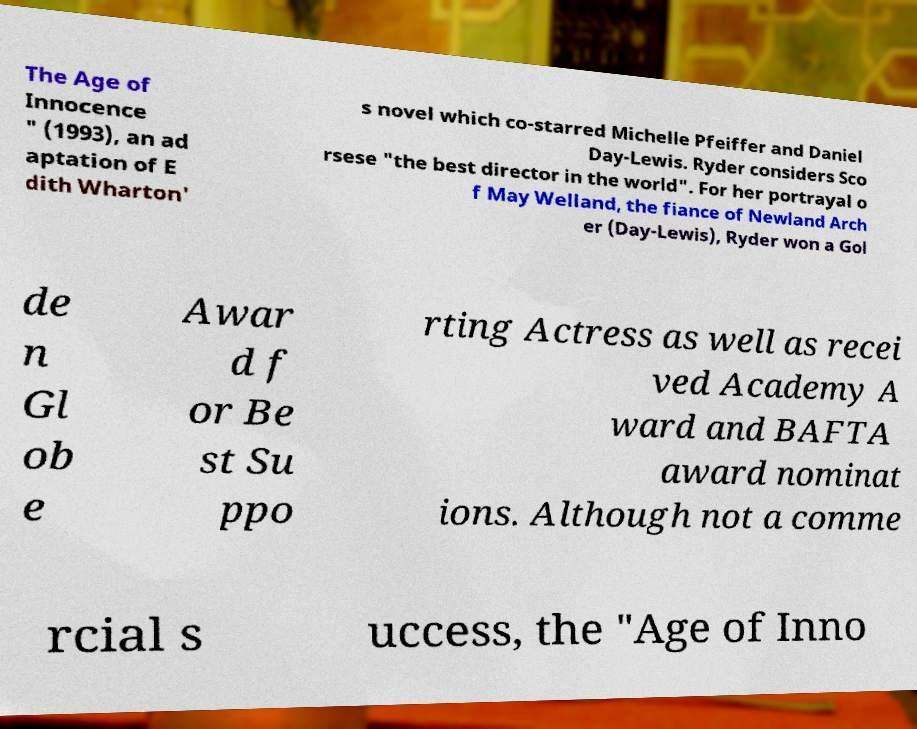For documentation purposes, I need the text within this image transcribed. Could you provide that? The Age of Innocence " (1993), an ad aptation of E dith Wharton' s novel which co-starred Michelle Pfeiffer and Daniel Day-Lewis. Ryder considers Sco rsese "the best director in the world". For her portrayal o f May Welland, the fiance of Newland Arch er (Day-Lewis), Ryder won a Gol de n Gl ob e Awar d f or Be st Su ppo rting Actress as well as recei ved Academy A ward and BAFTA award nominat ions. Although not a comme rcial s uccess, the "Age of Inno 